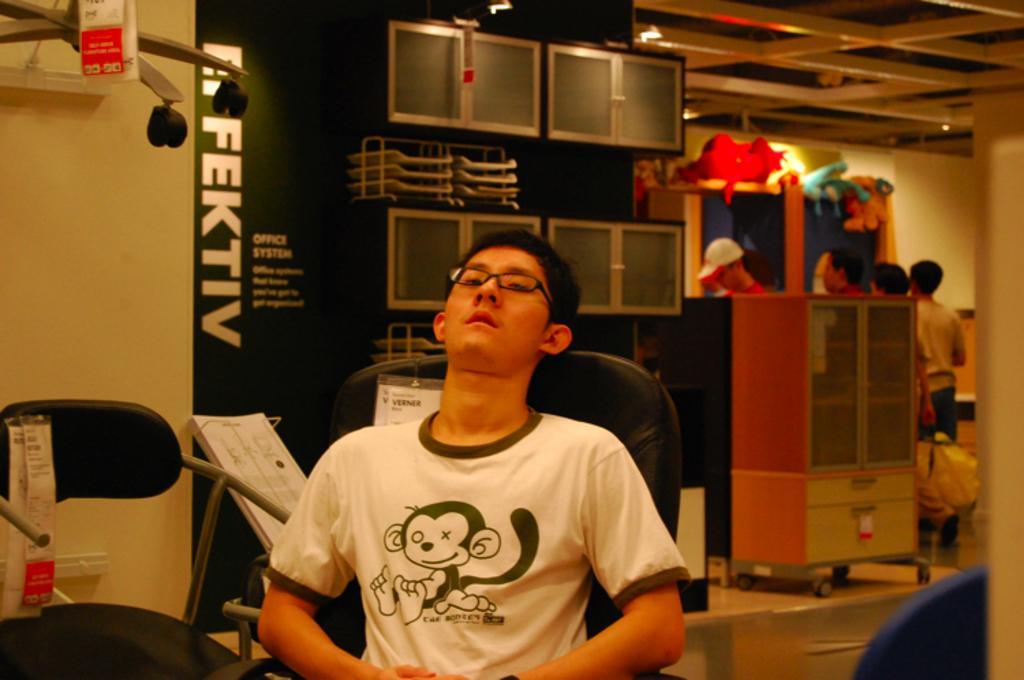Describe this image in one or two sentences. As we can see in the image there is a wall, banner, few people standing over here and the man is sitting on chair. 